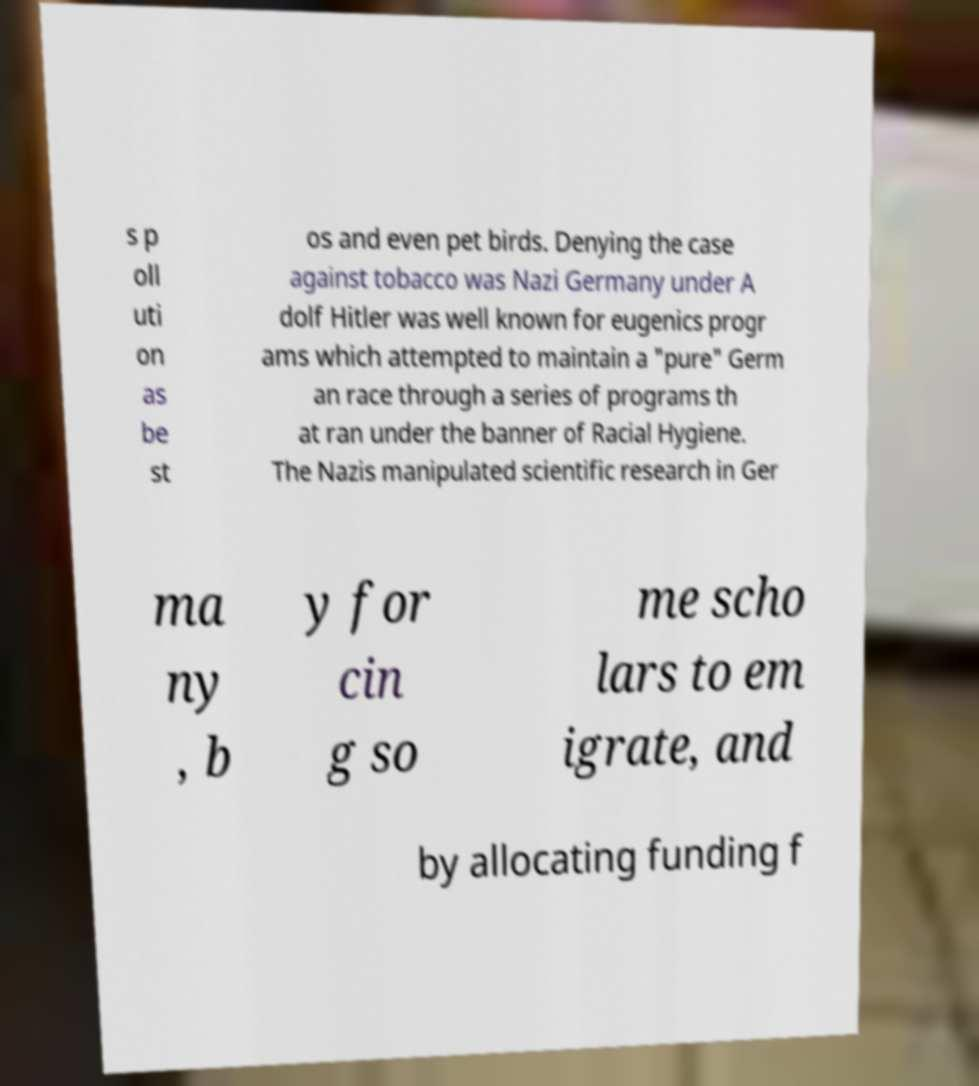I need the written content from this picture converted into text. Can you do that? s p oll uti on as be st os and even pet birds. Denying the case against tobacco was Nazi Germany under A dolf Hitler was well known for eugenics progr ams which attempted to maintain a "pure" Germ an race through a series of programs th at ran under the banner of Racial Hygiene. The Nazis manipulated scientific research in Ger ma ny , b y for cin g so me scho lars to em igrate, and by allocating funding f 